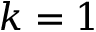<formula> <loc_0><loc_0><loc_500><loc_500>k = 1</formula> 